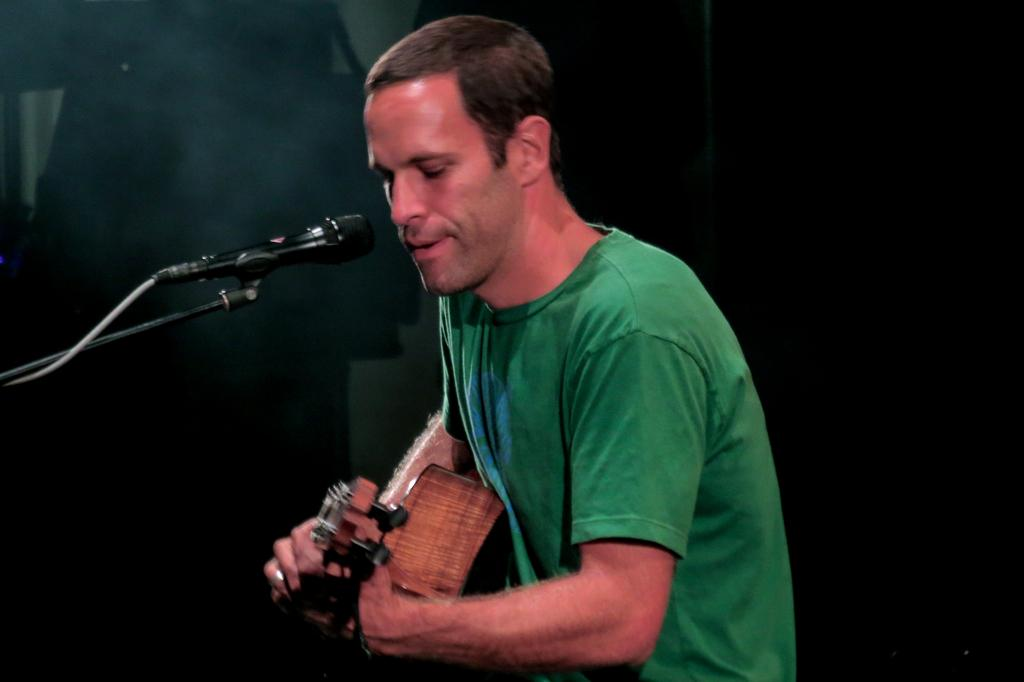What is the main subject of the image? The main subject of the image is a person. What is the person doing in the image? The person is playing a guitar. What object is in front of the person? There is a mic in front of the person. How would you describe the background of the image? The background of the image is dark. Can you tell me how many daughters the person in the image has? There is no information about the person's daughters in the image, so we cannot determine the number of daughters they have. Is there a cave visible in the background of the image? There is no cave present in the image; the background is dark, but no specific location or structure is mentioned. 